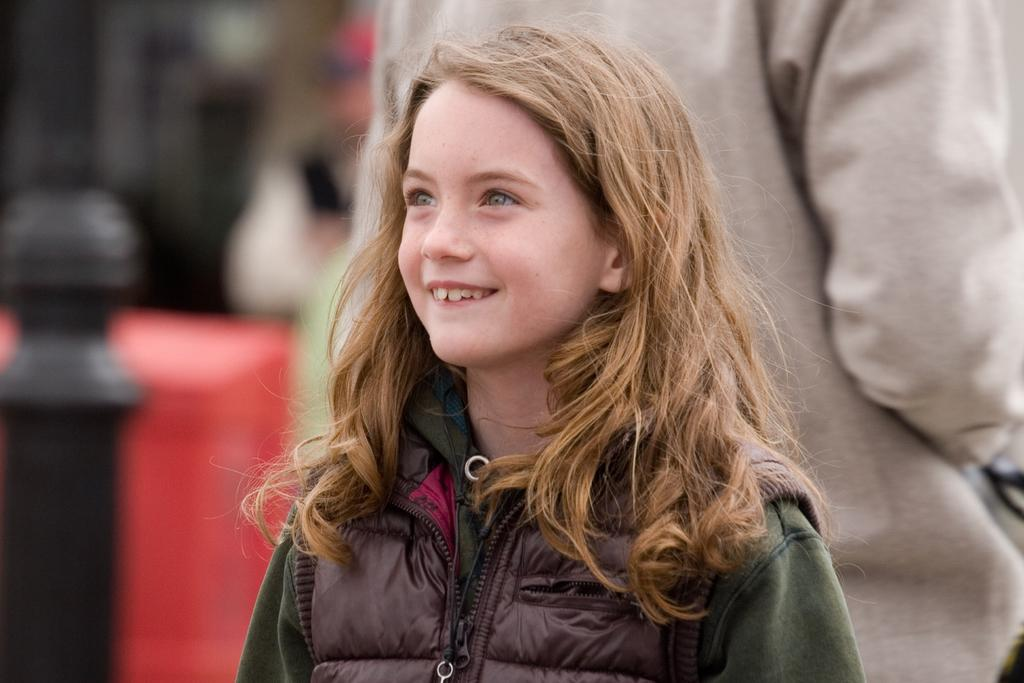What is the girl in the image doing? The girl is standing in the image and smiling. What can be seen in the image besides the girl? There is a black pole, a red object on the surface, and people in the background of the image. How are the people in the background depicted? The people in the background are blurred. What sense does the girl use to twist the red object in the image? The girl is not depicted as twisting any object in the image, and there is no mention of her using any sense to do so. 